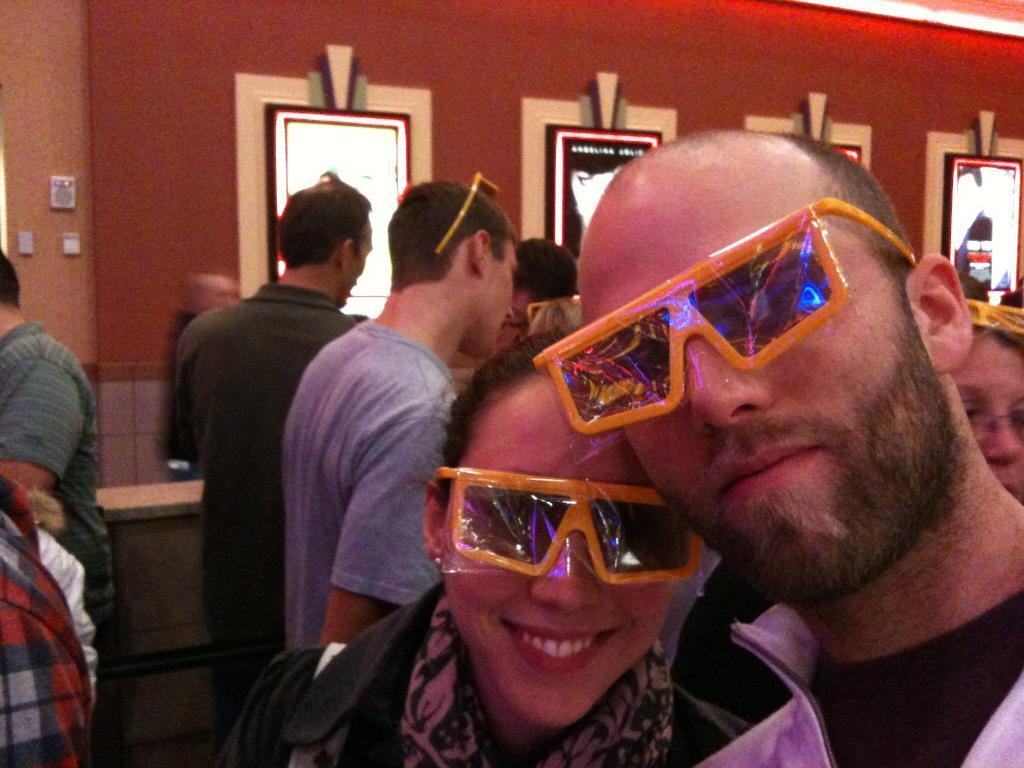How many people are in the image? There is a group of people in the image, but the exact number is not specified. What can be seen in the background of the image? There are switchboards in the background of the image. Can you describe the sidewalk in the image? There is no sidewalk present in the image. 